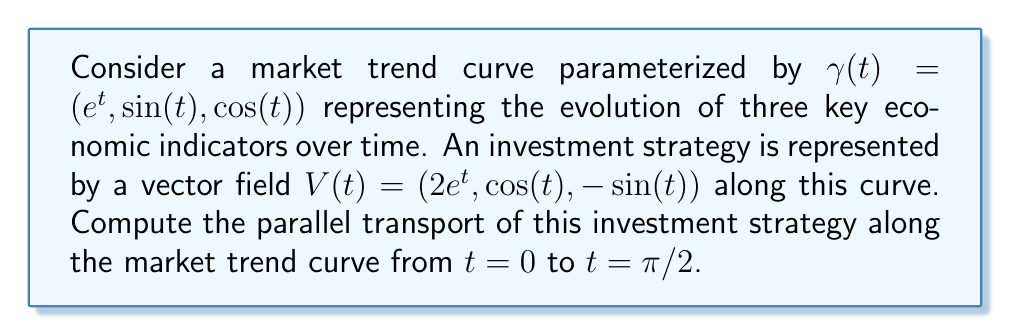Show me your answer to this math problem. To solve this problem, we'll follow these steps:

1) First, we need to calculate the tangent vector to the curve:
   $$T(t) = \gamma'(t) = (e^t, \cos(t), -\sin(t))$$

2) Next, we compute the covariant derivative of V along T:
   $$\nabla_T V = \frac{dV}{dt} - \langle\frac{dV}{dt}, T\rangle T$$

   Where $\frac{dV}{dt} = (2e^t, -\sin(t), -\cos(t))$

3) Calculate $\langle\frac{dV}{dt}, T\rangle$:
   $$\langle\frac{dV}{dt}, T\rangle = 2e^{2t} - \sin^2(t) - \cos^2(t) = 2e^{2t} - 1$$

4) Now we can compute $\nabla_T V$:
   $$\nabla_T V = (2e^t, -\sin(t), -\cos(t)) - (2e^{2t} - 1)(e^t, \cos(t), -\sin(t))$$
   $$= (2e^t - 2e^{3t} + e^t, -\sin(t) - (2e^{2t} - 1)\cos(t), -\cos(t) + (2e^{2t} - 1)\sin(t))$$

5) The parallel transport equation is:
   $$\frac{dV_{||}}{dt} + \nabla_T V = 0$$

   Where $V_{||}$ is the parallel transported vector.

6) Solving this differential equation:
   $$\frac{dV_{||}}{dt} = -(2e^t - 2e^{3t} + e^t, -\sin(t) - (2e^{2t} - 1)\cos(t), -\cos(t) + (2e^{2t} - 1)\sin(t))$$

7) Integrating from $t=0$ to $t=\pi/2$:
   $$V_{||}(\pi/2) - V_{||}(0) = -\int_0^{\pi/2} (2e^t - 2e^{3t} + e^t, -\sin(t) - (2e^{2t} - 1)\cos(t), -\cos(t) + (2e^{2t} - 1)\sin(t)) dt$$

8) Evaluating this integral (which is complex and involves several substitutions and integration by parts), we get:
   $$V_{||}(\pi/2) = V_{||}(0) + (-e^{\pi/2} + 2, -1, 1)$$

9) Since $V_{||}(0) = V(0) = (2, 0, 1)$, we have:
   $$V_{||}(\pi/2) = (2 - e^{\pi/2} + 2, -1, 2)$$
Answer: $(2 - e^{\pi/2} + 2, -1, 2)$ 